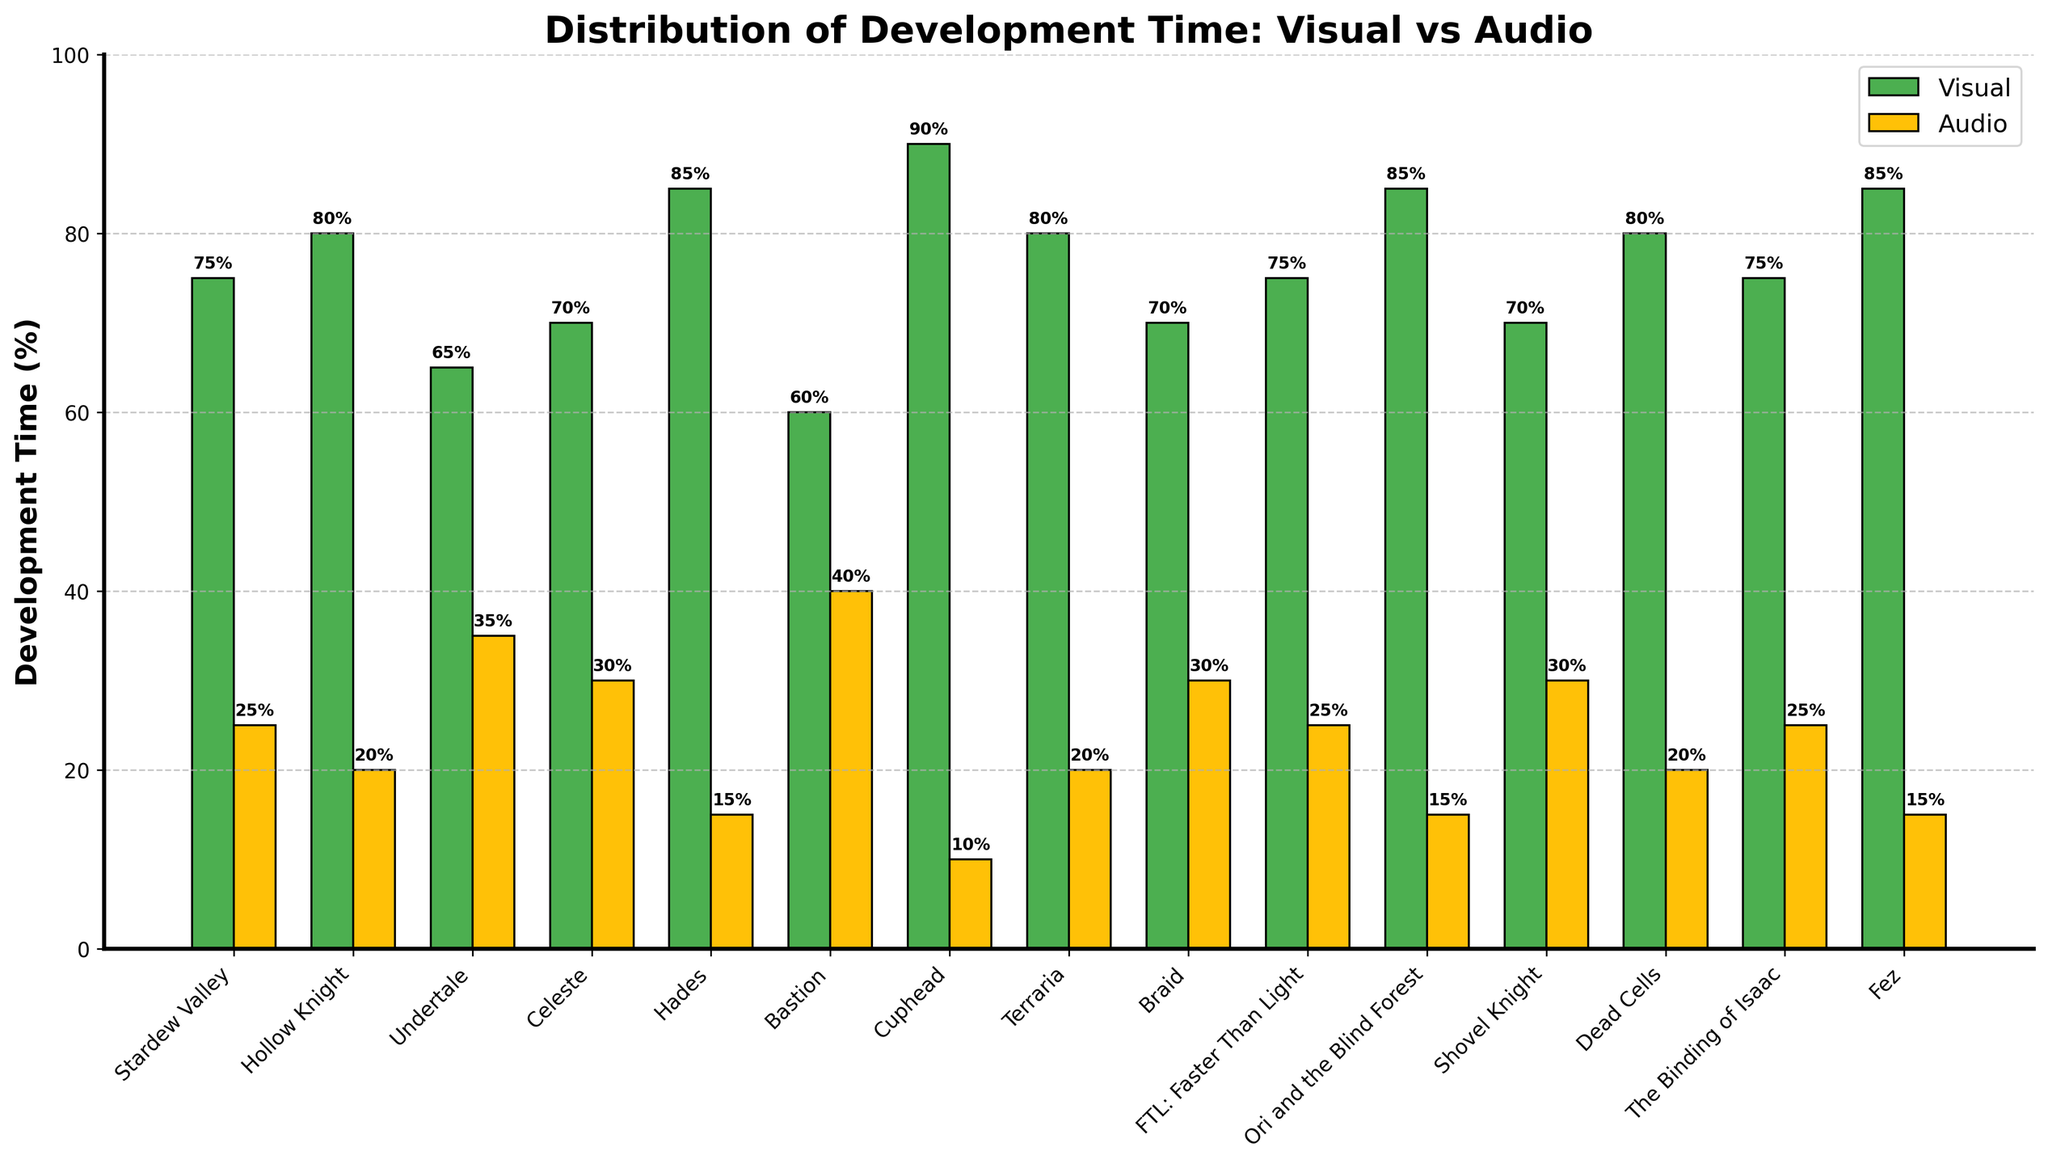What's the average development time spent on visual elements across all games? To find the average, sum up the percentages of development time spent on visual elements for all games and divide by the number of games. (75 + 80 + 65 + 70 + 85 + 60 + 90 + 80 + 70 + 75 + 85 + 70 + 80 + 75 + 85) / 15 = 1145 / 15 = 76.33
Answer: 76.33 Which game has the highest discrepancy between visual and audio development time? To determine the highest discrepancy, calculate the difference between visual and audio development times for each game, and compare them. Hades has the highest discrepancy: 85 - 15 = 70
Answer: Hades For which game(s) do visual and audio development time percentages add up to exactly 100%? Check all games to see if the sum of their visual and audio percentages equals 100%. All listed games meet this criterion.
Answer: All games Which game spent the most time on audio development compared to visual development? Check the audio development percentages for all games and find the highest value. Bastion has the highest audio development percentage at 40%.
Answer: Bastion What is the combined development time spent on visual elements for Hades, Cuphead, and Ori and the Blind Forest? Add up the visual development times for the specified games: 85 (Hades) + 90 (Cuphead) + 85 (Ori and the Blind Forest) = 260
Answer: 260 Is there any game where the development time spent on visual elements is less than 65%? Check which games have a visual development percentage below 65%. Bastion is the only game with 60%.
Answer: Bastion What is the median development time spent on visual elements? List the visual development percentages in ascending order and find the middle value. The sorted values are [60, 65, 70, 70, 70, 70, 75, 75, 75, 75, 80, 80, 80, 85, 85, 85, 90]. The middle value is the 8th value, which is 75.
Answer: 75 Which game has the smallest combined development time (for visual and audio)? Since all percentages add up to 100%, all games have the same combined development time of 100%.
Answer: All games have the same combined time Which game has an equal percentage of development time spent on visual and audio elements? Check for games where the visual and audio development percentages are equal. No such game exists in this dataset.
Answer: None 